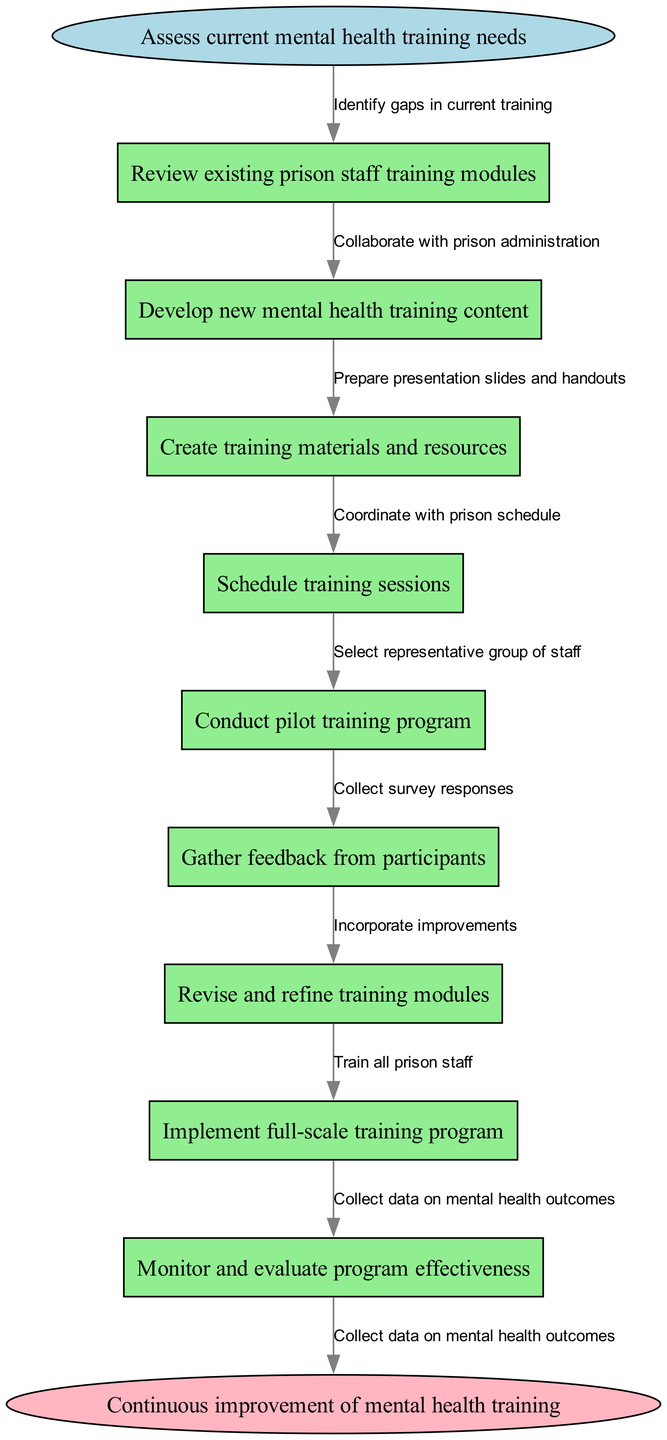What is the starting point of the workflow? The starting point is the node that initiates the workflow, indicated at the top of the flowchart. It is labeled as "Assess current mental health training needs."
Answer: Assess current mental health training needs How many nodes are there in the flowchart? To find the total number of nodes, we count the start node, all intermediate nodes listed, and the end node. There is one start node, nine intermediate nodes, and one end node, making it a total of eleven nodes.
Answer: 11 What is the last step before the end node? The last step before reaching the end node is the final node in the sequence of steps that transitions to the end node. This is labeled "Monitor and evaluate program effectiveness."
Answer: Monitor and evaluate program effectiveness What is the first edge connecting to the first node? The first edge represents the relationship between the start node and the first intermediate node. It details the action taken from the start point. The first edge is labeled "Identify gaps in current training."
Answer: Identify gaps in current training What is the relationship between "Conduct pilot training program" and "Gather feedback from participants"? The relationship can be identified by observing the arrows that connect the two nodes. The edge that connects them indicates the progression of actions flowing from one to the other, labeled as "Select representative group of staff."
Answer: Select representative group of staff What happens after "Revise and refine training modules"? After this step, the next action can be determined by looking at the subsequent connection to the next node in the sequence. This step leads to the implementation of the training program as indicated by the edge "Train all prison staff.”
Answer: Train all prison staff Which node follows "Schedule training sessions"? This can be determined by examining the flow of the diagram and identifying the sequence of actions connected to the node "Schedule training sessions." The next step is "Conduct pilot training program."
Answer: Conduct pilot training program How does feedback influence the training modules? Feedback can influence the training modules through the edge labeled "Incorporate improvements," which shows that participant feedback is utilized to enhance the training content.
Answer: Incorporate improvements 